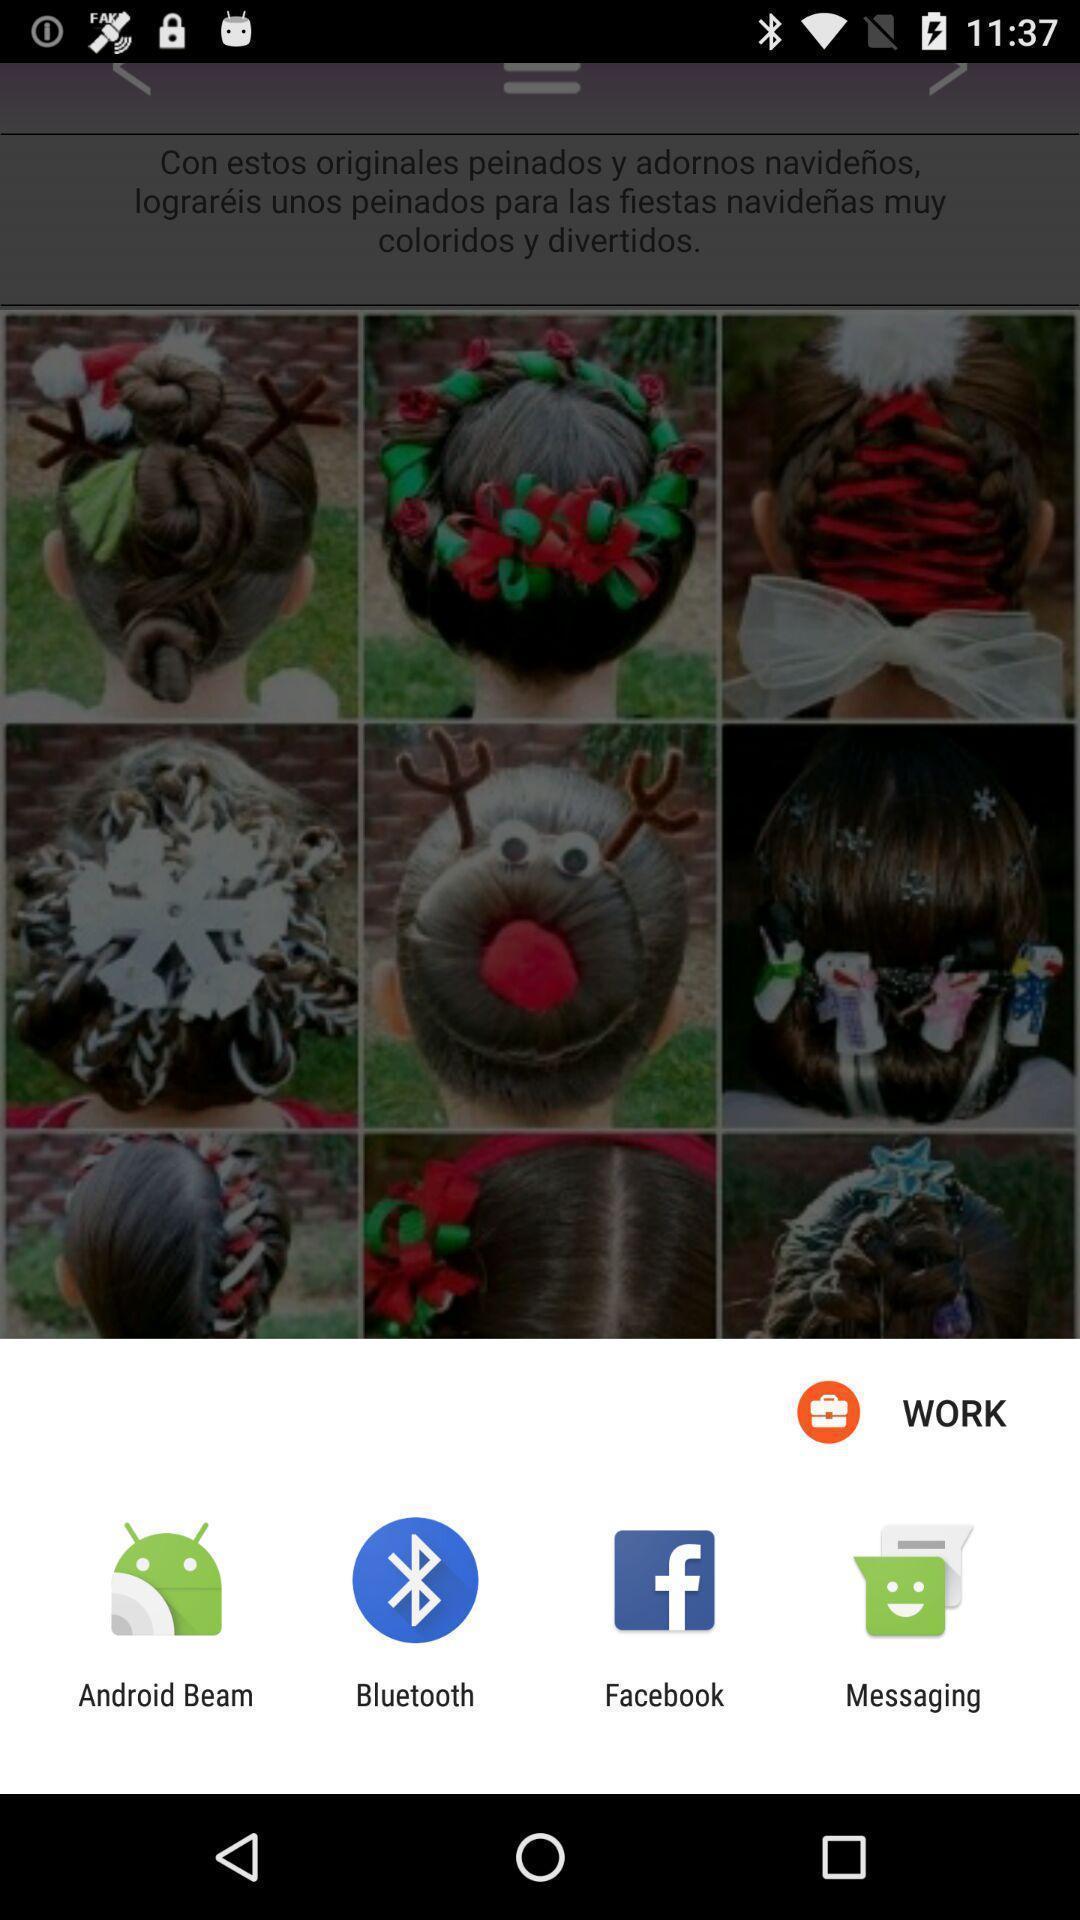Give me a summary of this screen capture. Share options page of a hair style app. 